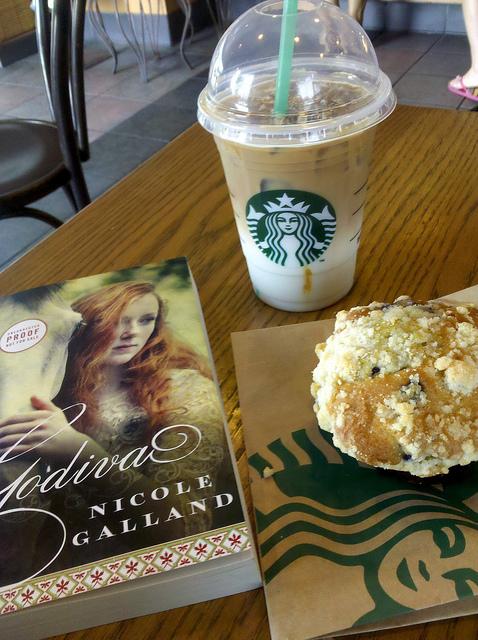Is that a hardcover or softcover book?
Keep it brief. Softcover. What is the name of this business?
Give a very brief answer. Starbucks. Is that a muffin or a pastry?
Answer briefly. Muffin. 